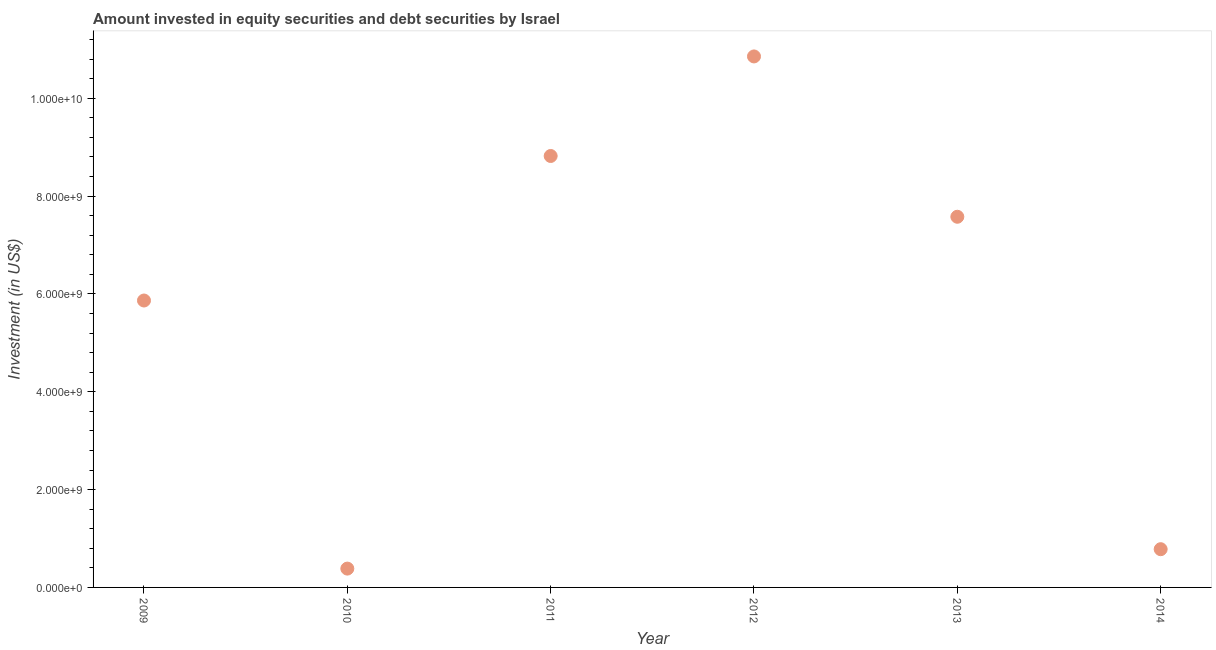What is the portfolio investment in 2012?
Provide a succinct answer. 1.09e+1. Across all years, what is the maximum portfolio investment?
Keep it short and to the point. 1.09e+1. Across all years, what is the minimum portfolio investment?
Your answer should be very brief. 3.85e+08. What is the sum of the portfolio investment?
Offer a terse response. 3.43e+1. What is the difference between the portfolio investment in 2011 and 2013?
Your answer should be compact. 1.24e+09. What is the average portfolio investment per year?
Your response must be concise. 5.71e+09. What is the median portfolio investment?
Your response must be concise. 6.72e+09. In how many years, is the portfolio investment greater than 10400000000 US$?
Your response must be concise. 1. What is the ratio of the portfolio investment in 2011 to that in 2012?
Provide a succinct answer. 0.81. What is the difference between the highest and the second highest portfolio investment?
Provide a succinct answer. 2.04e+09. What is the difference between the highest and the lowest portfolio investment?
Provide a succinct answer. 1.05e+1. Does the portfolio investment monotonically increase over the years?
Make the answer very short. No. How many dotlines are there?
Your response must be concise. 1. How many years are there in the graph?
Offer a terse response. 6. What is the difference between two consecutive major ticks on the Y-axis?
Offer a very short reply. 2.00e+09. Are the values on the major ticks of Y-axis written in scientific E-notation?
Your response must be concise. Yes. Does the graph contain any zero values?
Give a very brief answer. No. What is the title of the graph?
Your answer should be very brief. Amount invested in equity securities and debt securities by Israel. What is the label or title of the Y-axis?
Offer a very short reply. Investment (in US$). What is the Investment (in US$) in 2009?
Make the answer very short. 5.86e+09. What is the Investment (in US$) in 2010?
Ensure brevity in your answer.  3.85e+08. What is the Investment (in US$) in 2011?
Give a very brief answer. 8.82e+09. What is the Investment (in US$) in 2012?
Ensure brevity in your answer.  1.09e+1. What is the Investment (in US$) in 2013?
Provide a short and direct response. 7.58e+09. What is the Investment (in US$) in 2014?
Your answer should be very brief. 7.82e+08. What is the difference between the Investment (in US$) in 2009 and 2010?
Provide a short and direct response. 5.48e+09. What is the difference between the Investment (in US$) in 2009 and 2011?
Offer a terse response. -2.95e+09. What is the difference between the Investment (in US$) in 2009 and 2012?
Provide a short and direct response. -4.99e+09. What is the difference between the Investment (in US$) in 2009 and 2013?
Make the answer very short. -1.71e+09. What is the difference between the Investment (in US$) in 2009 and 2014?
Provide a succinct answer. 5.08e+09. What is the difference between the Investment (in US$) in 2010 and 2011?
Offer a terse response. -8.43e+09. What is the difference between the Investment (in US$) in 2010 and 2012?
Your response must be concise. -1.05e+1. What is the difference between the Investment (in US$) in 2010 and 2013?
Make the answer very short. -7.19e+09. What is the difference between the Investment (in US$) in 2010 and 2014?
Provide a succinct answer. -3.97e+08. What is the difference between the Investment (in US$) in 2011 and 2012?
Your response must be concise. -2.04e+09. What is the difference between the Investment (in US$) in 2011 and 2013?
Make the answer very short. 1.24e+09. What is the difference between the Investment (in US$) in 2011 and 2014?
Your answer should be very brief. 8.04e+09. What is the difference between the Investment (in US$) in 2012 and 2013?
Your answer should be very brief. 3.28e+09. What is the difference between the Investment (in US$) in 2012 and 2014?
Your answer should be compact. 1.01e+1. What is the difference between the Investment (in US$) in 2013 and 2014?
Your answer should be very brief. 6.80e+09. What is the ratio of the Investment (in US$) in 2009 to that in 2010?
Provide a short and direct response. 15.24. What is the ratio of the Investment (in US$) in 2009 to that in 2011?
Your answer should be very brief. 0.67. What is the ratio of the Investment (in US$) in 2009 to that in 2012?
Give a very brief answer. 0.54. What is the ratio of the Investment (in US$) in 2009 to that in 2013?
Provide a succinct answer. 0.77. What is the ratio of the Investment (in US$) in 2009 to that in 2014?
Offer a very short reply. 7.5. What is the ratio of the Investment (in US$) in 2010 to that in 2011?
Make the answer very short. 0.04. What is the ratio of the Investment (in US$) in 2010 to that in 2012?
Provide a succinct answer. 0.04. What is the ratio of the Investment (in US$) in 2010 to that in 2013?
Your answer should be very brief. 0.05. What is the ratio of the Investment (in US$) in 2010 to that in 2014?
Offer a terse response. 0.49. What is the ratio of the Investment (in US$) in 2011 to that in 2012?
Provide a succinct answer. 0.81. What is the ratio of the Investment (in US$) in 2011 to that in 2013?
Provide a succinct answer. 1.16. What is the ratio of the Investment (in US$) in 2011 to that in 2014?
Provide a short and direct response. 11.28. What is the ratio of the Investment (in US$) in 2012 to that in 2013?
Provide a short and direct response. 1.43. What is the ratio of the Investment (in US$) in 2012 to that in 2014?
Your response must be concise. 13.89. What is the ratio of the Investment (in US$) in 2013 to that in 2014?
Ensure brevity in your answer.  9.69. 